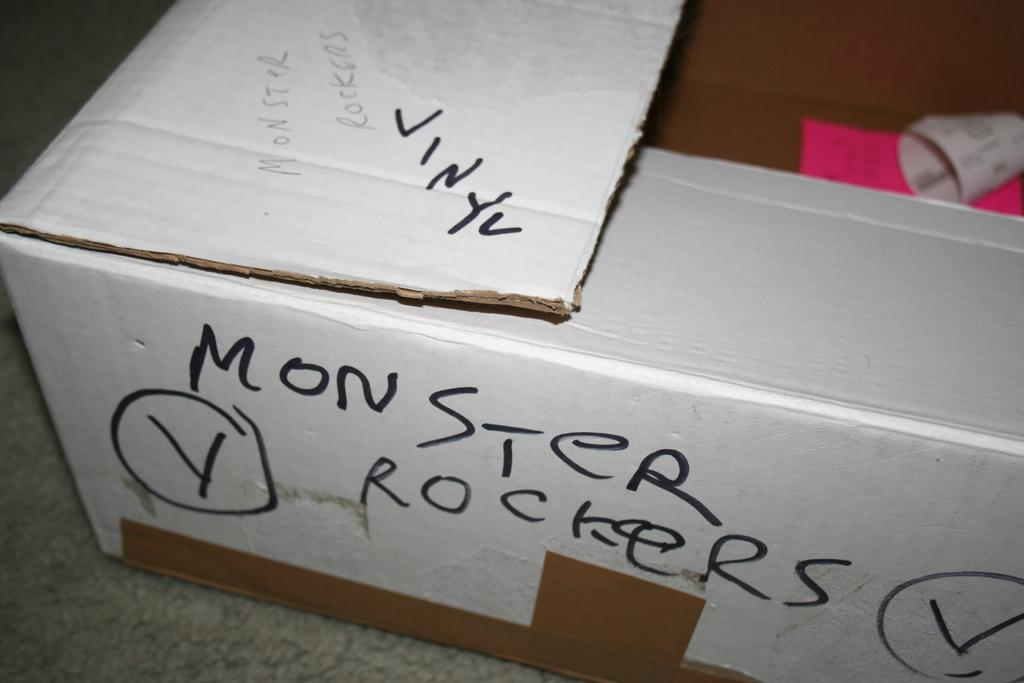<image>
Render a clear and concise summary of the photo. A white box has Monster Rockers written on the side in black marker. 